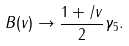Convert formula to latex. <formula><loc_0><loc_0><loc_500><loc_500>B ( v ) \to \frac { 1 + \slash { v } } { 2 } \gamma _ { 5 } .</formula> 